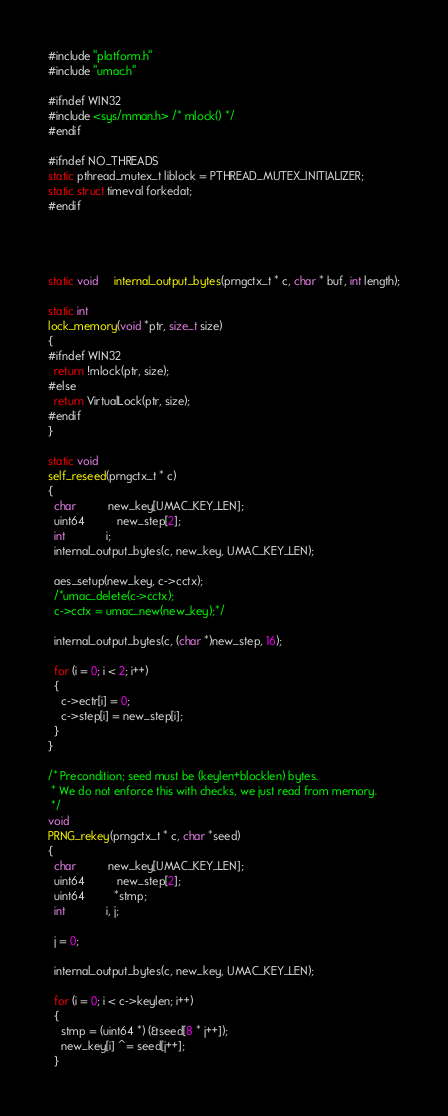Convert code to text. <code><loc_0><loc_0><loc_500><loc_500><_C_>#include "platform.h"
#include "umac.h"

#ifndef WIN32
#include <sys/mman.h> /* mlock() */
#endif

#ifndef NO_THREADS
static pthread_mutex_t liblock = PTHREAD_MUTEX_INITIALIZER;
static struct timeval forkedat;
#endif




static void     internal_output_bytes(prngctx_t * c, char * buf, int length);

static int
lock_memory(void *ptr, size_t size)
{
#ifndef WIN32
  return !mlock(ptr, size);
#else
  return VirtualLock(ptr, size);
#endif
}

static void
self_reseed(prngctx_t * c)
{
  char          new_key[UMAC_KEY_LEN];
  uint64          new_step[2];
  int             i;
  internal_output_bytes(c, new_key, UMAC_KEY_LEN);

  aes_setup(new_key, c->cctx);
  /*umac_delete(c->cctx);
  c->cctx = umac_new(new_key);*/

  internal_output_bytes(c, (char *)new_step, 16);

  for (i = 0; i < 2; i++)
  {
    c->ectr[i] = 0;
    c->step[i] = new_step[i];
  }
}

/* Precondition; seed must be (keylen+blocklen) bytes. 
 * We do not enforce this with checks, we just read from memory.
 */
void
PRNG_rekey(prngctx_t * c, char *seed)
{
  char          new_key[UMAC_KEY_LEN];
  uint64          new_step[2];
  uint64         *stmp;
  int             i, j;

  j = 0;

  internal_output_bytes(c, new_key, UMAC_KEY_LEN);
  
  for (i = 0; i < c->keylen; i++)
  {
    stmp = (uint64 *) (&seed[8 * j++]);
    new_key[i] ^= seed[j++];
  }
</code> 